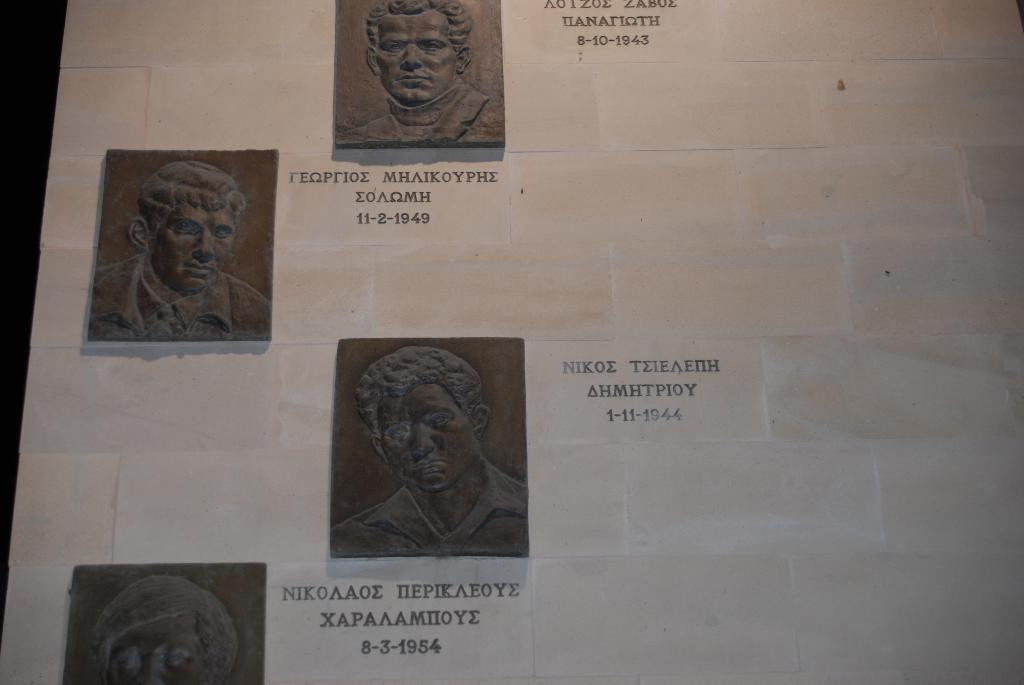What type of artwork is featured in the image? There are carved sculptures in the image. What additional information can be found on the sculptures? The sculptures have dates and names on them. Where are the sculptures located in the image? The sculptures are on a wall. What type of book is being used to point at the oven in the image? There is no book or oven present in the image; it features carved sculptures on a wall. 